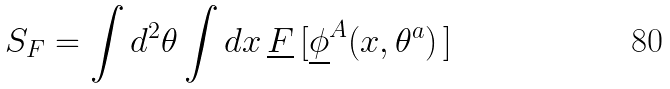<formula> <loc_0><loc_0><loc_500><loc_500>S _ { F } = \int d ^ { 2 } \theta \int d x \, \underline { F } \, [ { \underline { \phi } } ^ { A } ( x , \theta ^ { a } ) \, ]</formula> 